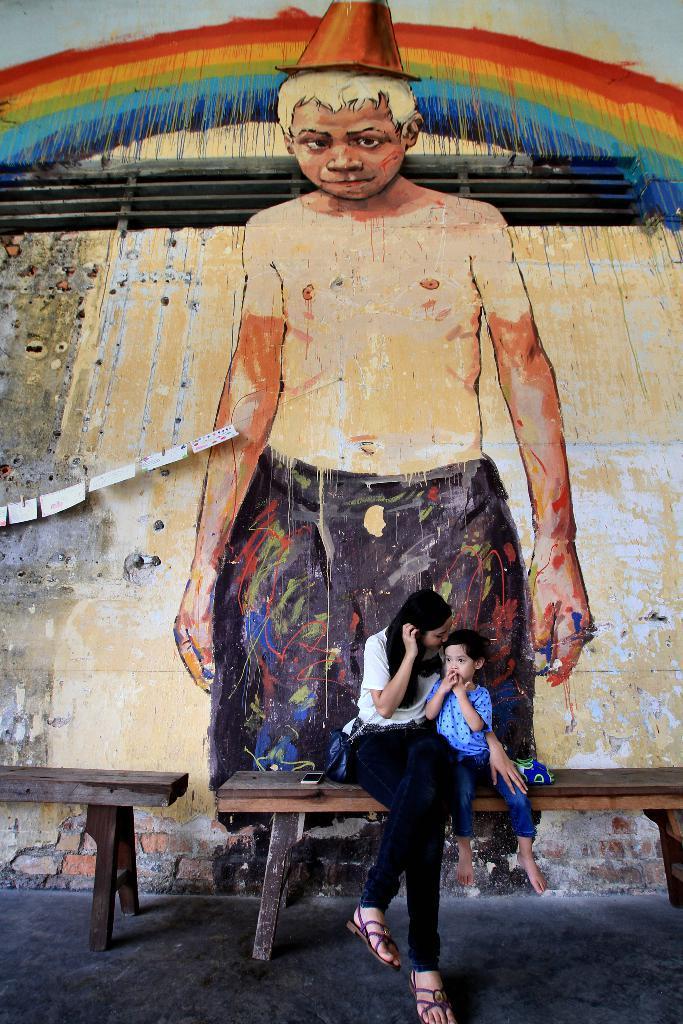Can you describe this image briefly? There are benches. On the bench there is a lady and a child is sitting. Also there is a mobile on the bench. In the back there is a wall with a painting of rainbow and a person wearing cap. 